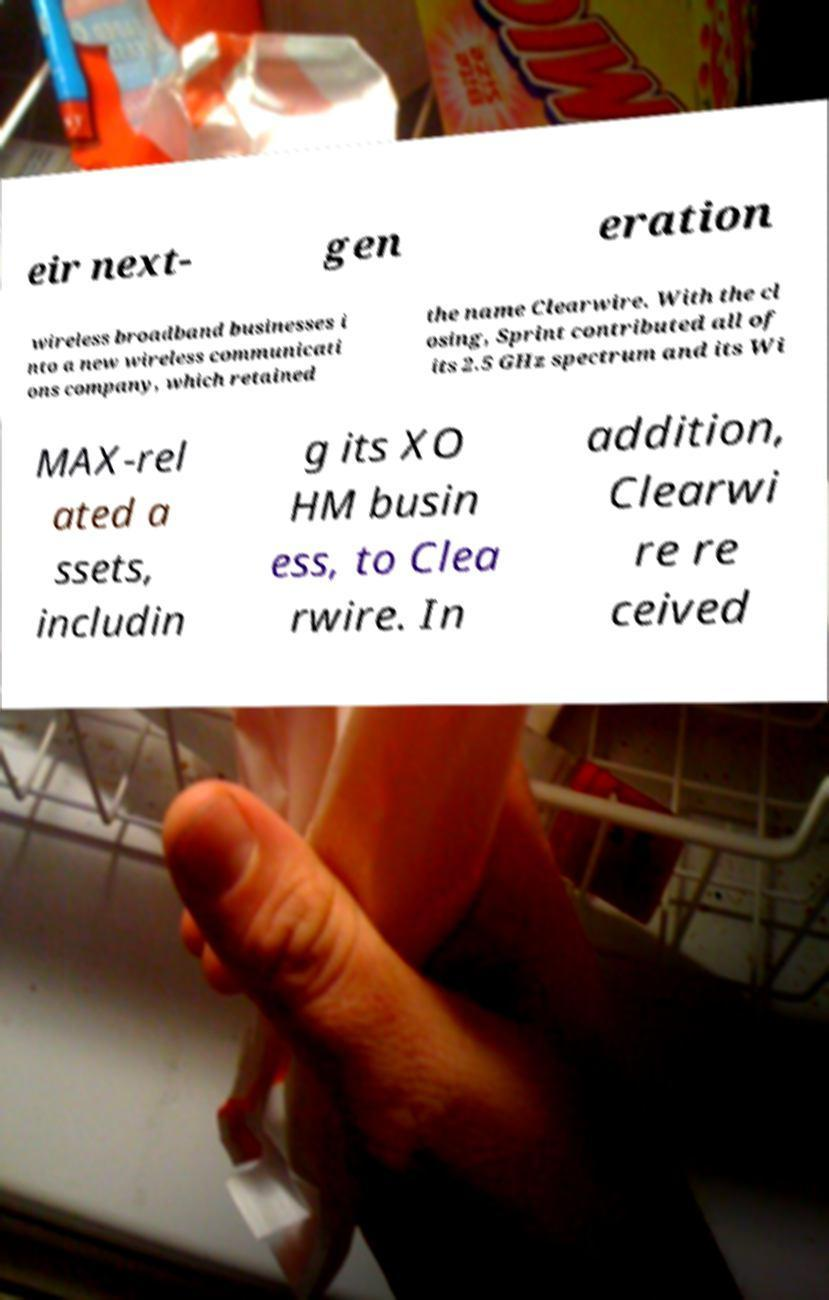Can you accurately transcribe the text from the provided image for me? eir next- gen eration wireless broadband businesses i nto a new wireless communicati ons company, which retained the name Clearwire. With the cl osing, Sprint contributed all of its 2.5 GHz spectrum and its Wi MAX-rel ated a ssets, includin g its XO HM busin ess, to Clea rwire. In addition, Clearwi re re ceived 